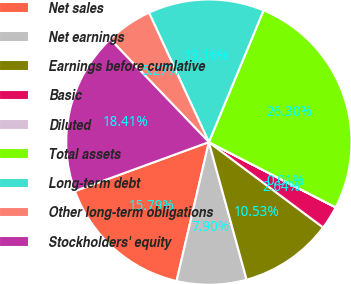Convert chart. <chart><loc_0><loc_0><loc_500><loc_500><pie_chart><fcel>Net sales<fcel>Net earnings<fcel>Earnings before cumlative<fcel>Basic<fcel>Diluted<fcel>Total assets<fcel>Long-term debt<fcel>Other long-term obligations<fcel>Stockholders' equity<nl><fcel>15.79%<fcel>7.9%<fcel>10.53%<fcel>2.64%<fcel>0.01%<fcel>26.3%<fcel>13.16%<fcel>5.27%<fcel>18.41%<nl></chart> 